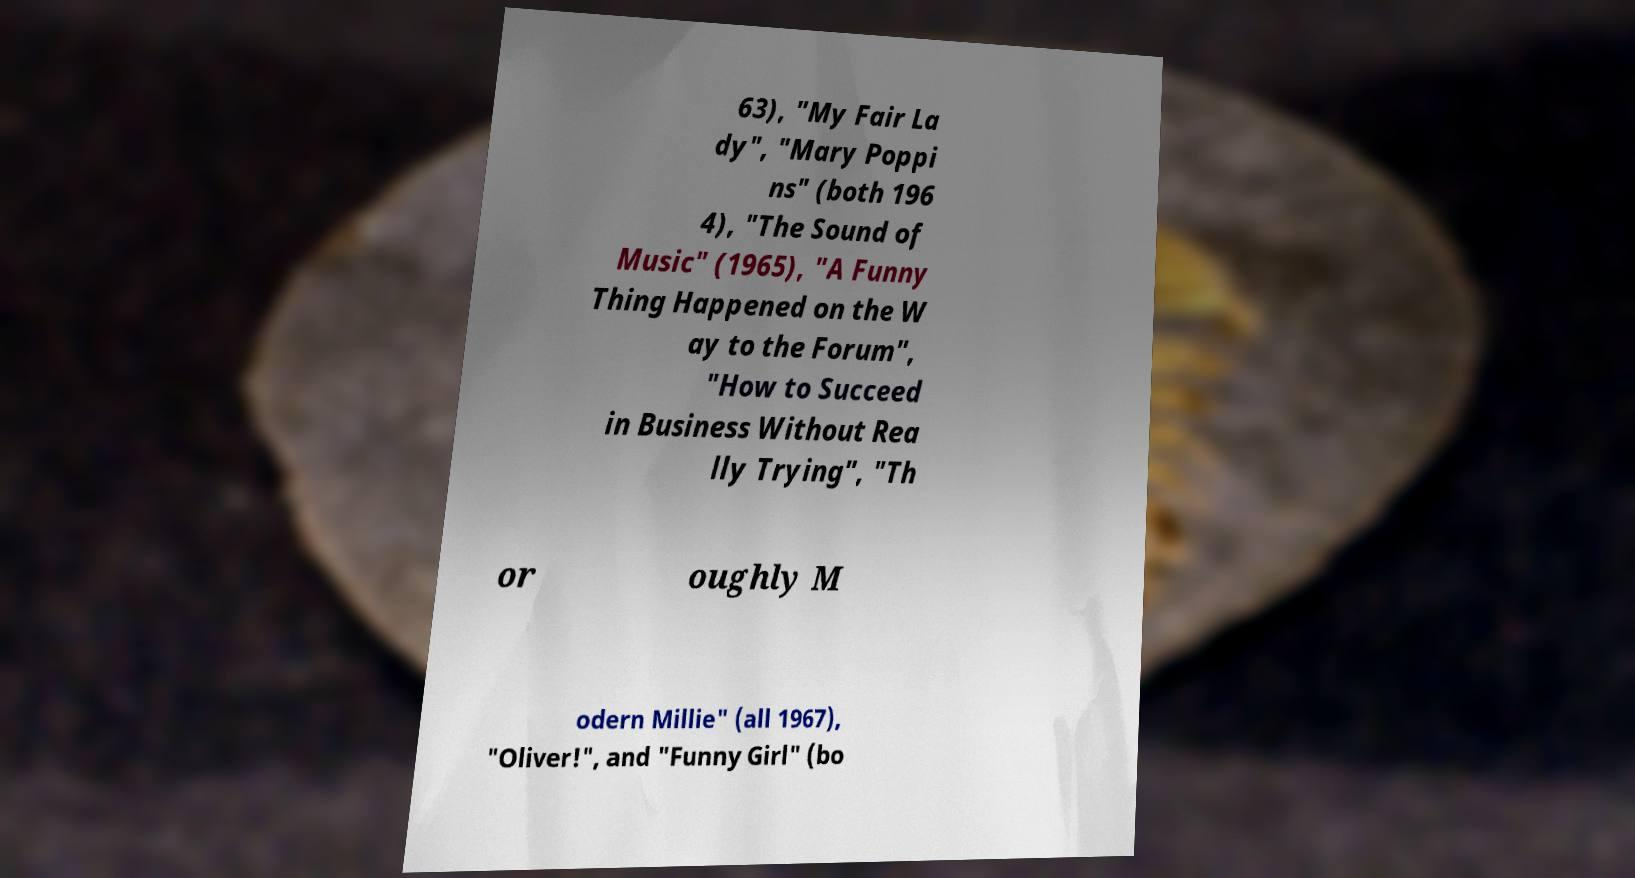I need the written content from this picture converted into text. Can you do that? 63), "My Fair La dy", "Mary Poppi ns" (both 196 4), "The Sound of Music" (1965), "A Funny Thing Happened on the W ay to the Forum", "How to Succeed in Business Without Rea lly Trying", "Th or oughly M odern Millie" (all 1967), "Oliver!", and "Funny Girl" (bo 